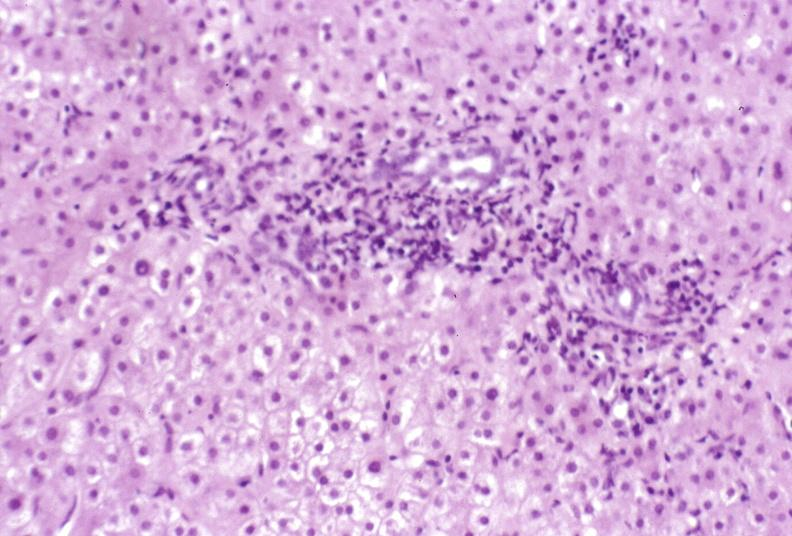s atrophy secondary to pituitectomy present?
Answer the question using a single word or phrase. No 